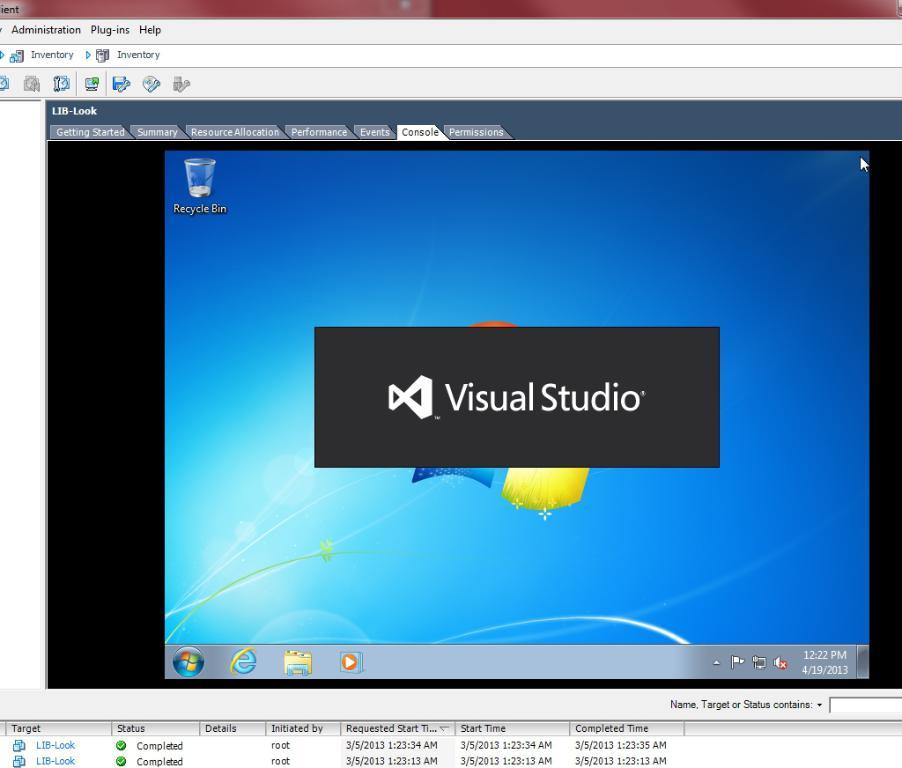Provide a one-sentence caption for the provided image. A close up of a computer monitor that says Visual Studio. 